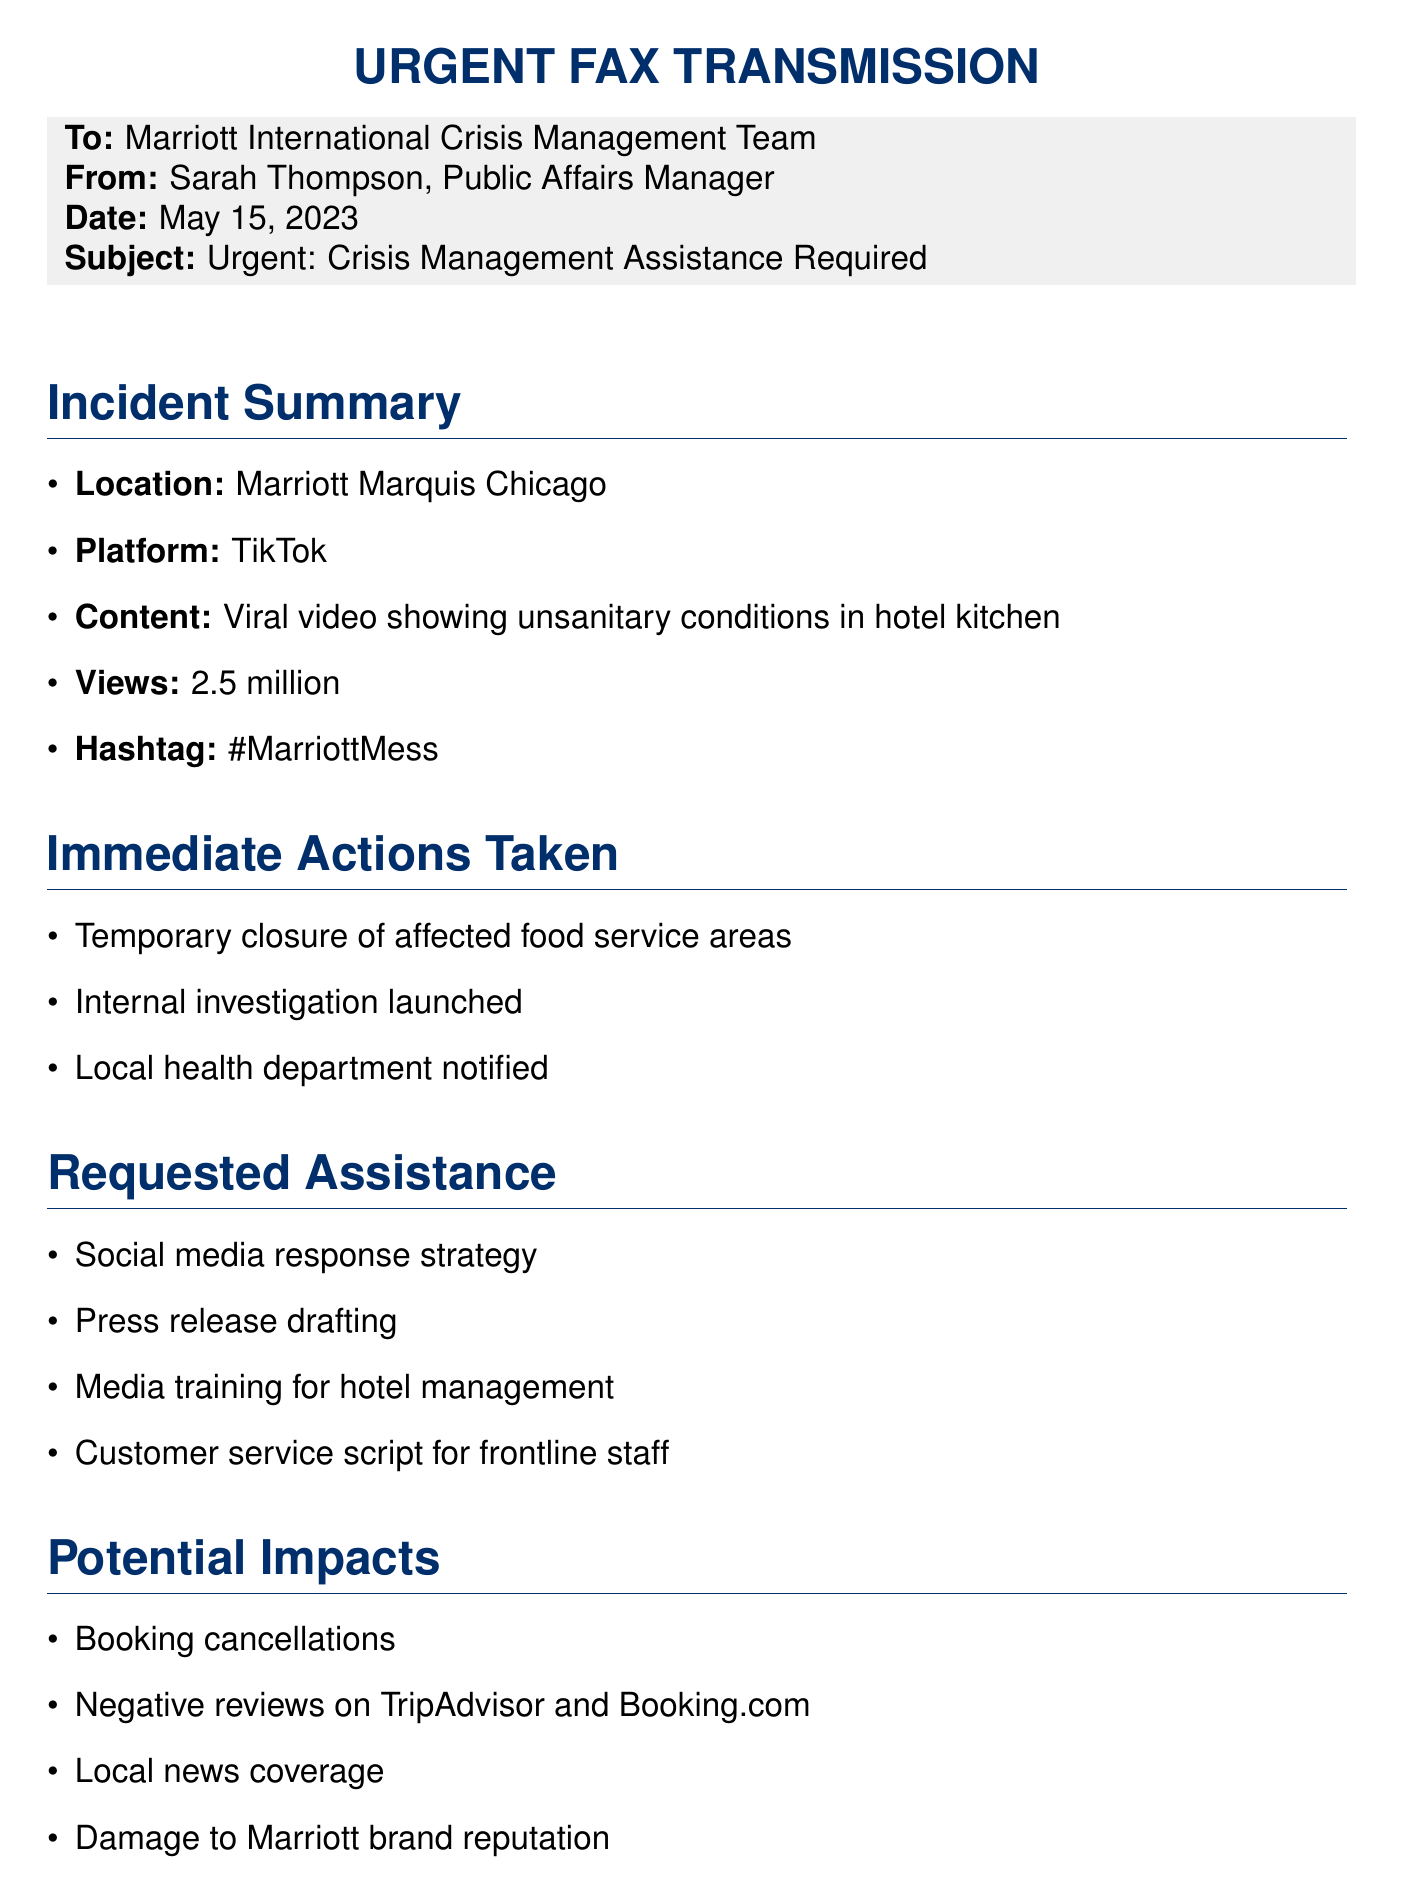What is the location of the incident? The incident occurred at the Marriott Marquis Chicago, which is stated in the incident summary.
Answer: Marriott Marquis Chicago What platform was the viral video posted on? The document specifies the platform where the video was posted as TikTok.
Answer: TikTok How many views did the video receive? The document indicates the video received 2.5 million views.
Answer: 2.5 million What is the hashtag associated with the viral video? The hashtag mentioned in the document is a key detail that identifies the incident in social media.
Answer: #MarriottMess What immediate action was taken regarding food service areas? The document notes that there was a temporary closure of affected food service areas as an immediate action.
Answer: Temporary closure What type of strategy is being requested for social media? The document explicitly mentions a social media response strategy as part of the requested assistance.
Answer: Social media response strategy Which department was notified following the incident? The document states that the local health department was notified as part of the immediate actions taken.
Answer: Local health department What potential impact involves booking activities? The document identifies booking cancellations as a potential impact of the incident.
Answer: Booking cancellations When was the video posted? The document provides the date and time the video was posted as important information regarding the incident timeline.
Answer: May 14, 2023, 8:30 PM CST 